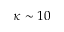Convert formula to latex. <formula><loc_0><loc_0><loc_500><loc_500>\kappa \sim 1 0</formula> 